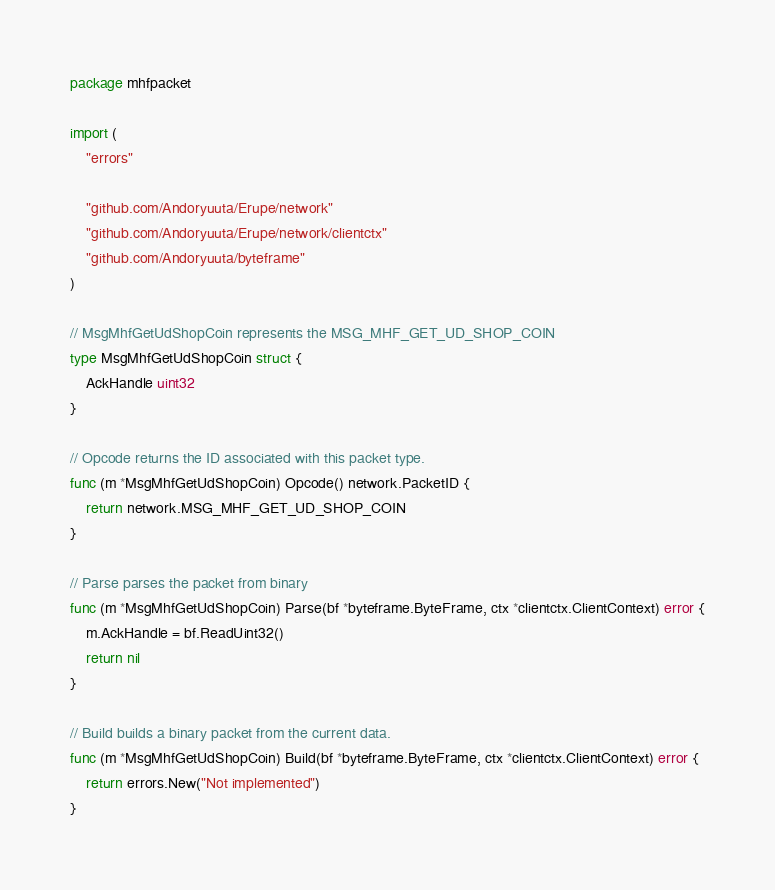Convert code to text. <code><loc_0><loc_0><loc_500><loc_500><_Go_>package mhfpacket

import (
	"errors"

	"github.com/Andoryuuta/Erupe/network"
	"github.com/Andoryuuta/Erupe/network/clientctx"
	"github.com/Andoryuuta/byteframe"
)

// MsgMhfGetUdShopCoin represents the MSG_MHF_GET_UD_SHOP_COIN
type MsgMhfGetUdShopCoin struct {
	AckHandle uint32
}

// Opcode returns the ID associated with this packet type.
func (m *MsgMhfGetUdShopCoin) Opcode() network.PacketID {
	return network.MSG_MHF_GET_UD_SHOP_COIN
}

// Parse parses the packet from binary
func (m *MsgMhfGetUdShopCoin) Parse(bf *byteframe.ByteFrame, ctx *clientctx.ClientContext) error {
	m.AckHandle = bf.ReadUint32()
	return nil
}

// Build builds a binary packet from the current data.
func (m *MsgMhfGetUdShopCoin) Build(bf *byteframe.ByteFrame, ctx *clientctx.ClientContext) error {
	return errors.New("Not implemented")
}
</code> 